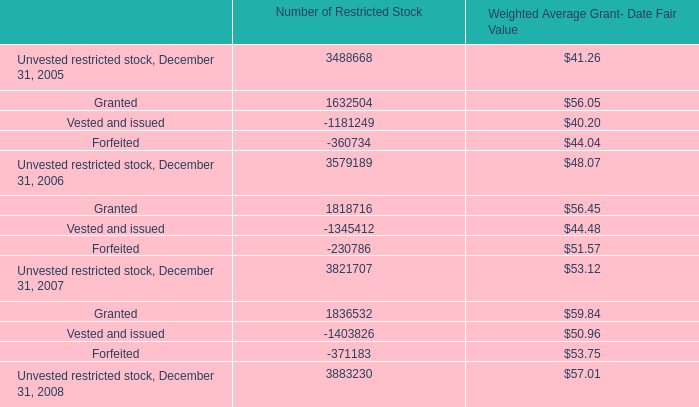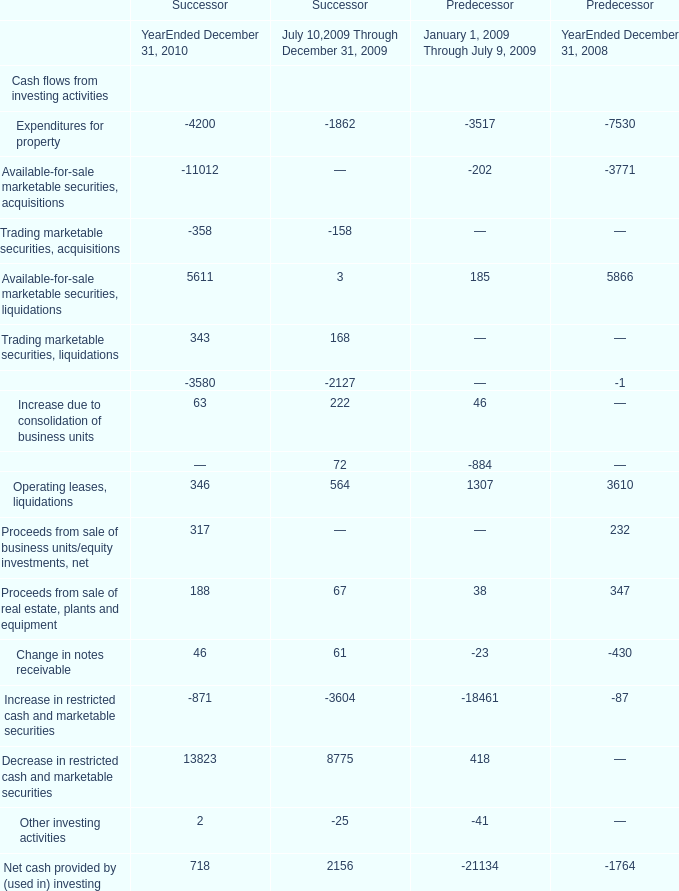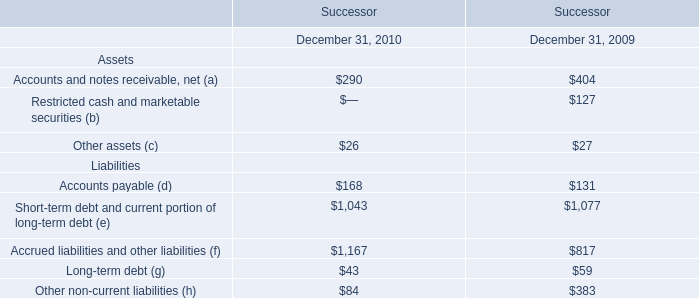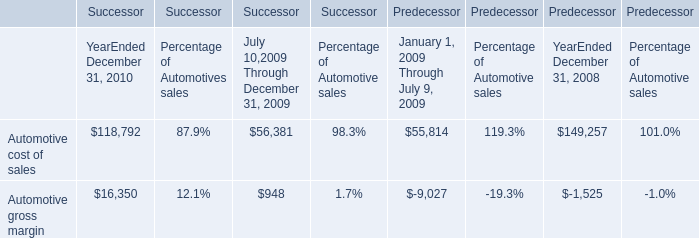What is the sum of the Available-for-sale marketable securities, liquidations in the years where Proceeds from sale of real estate, plants and equipment is greater than 100? 
Computations: (5611 + 5866)
Answer: 11477.0. 